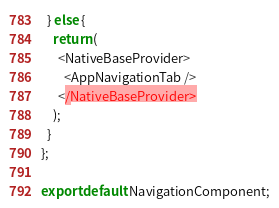<code> <loc_0><loc_0><loc_500><loc_500><_JavaScript_>  } else {
    return (
      <NativeBaseProvider>
        <AppNavigationTab />
      </NativeBaseProvider>
    );
  }
};

export default NavigationComponent;
</code> 